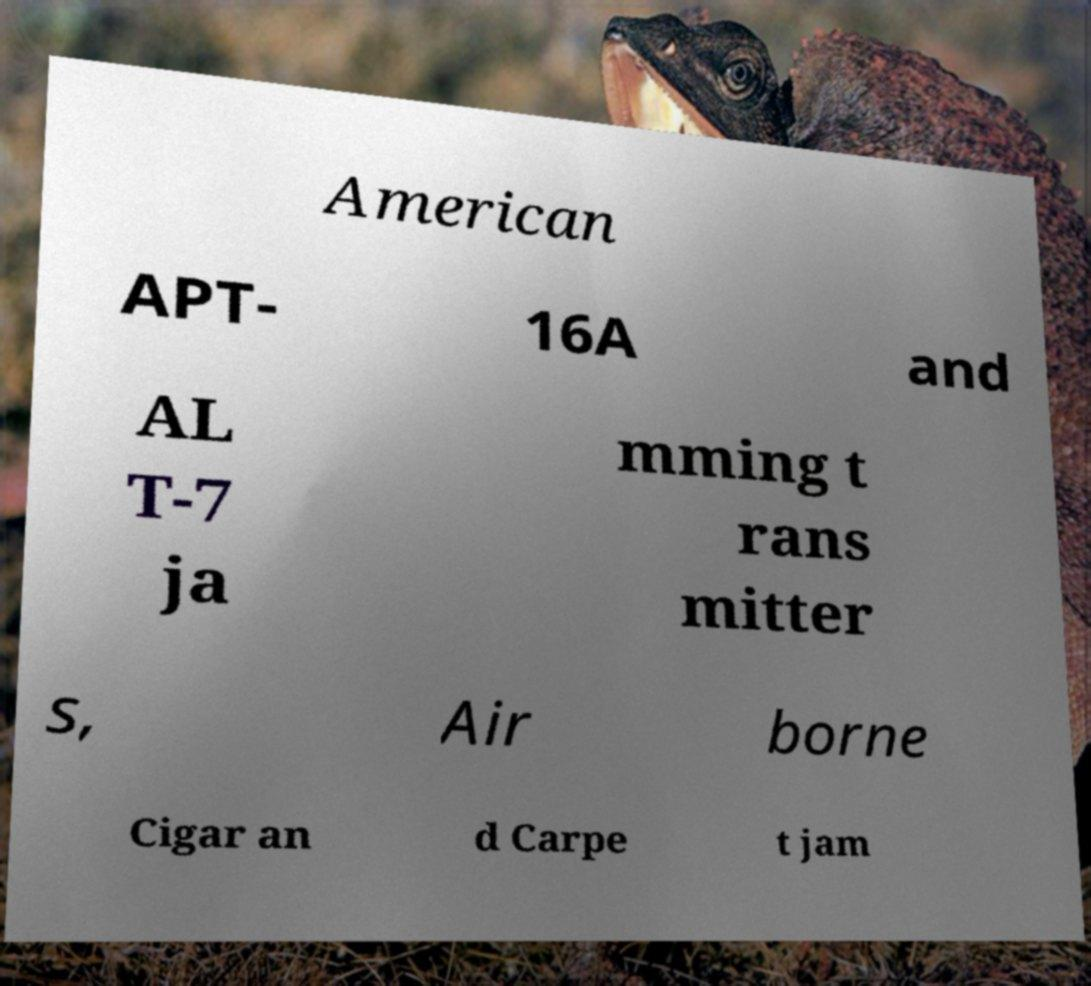Could you assist in decoding the text presented in this image and type it out clearly? American APT- 16A and AL T-7 ja mming t rans mitter s, Air borne Cigar an d Carpe t jam 